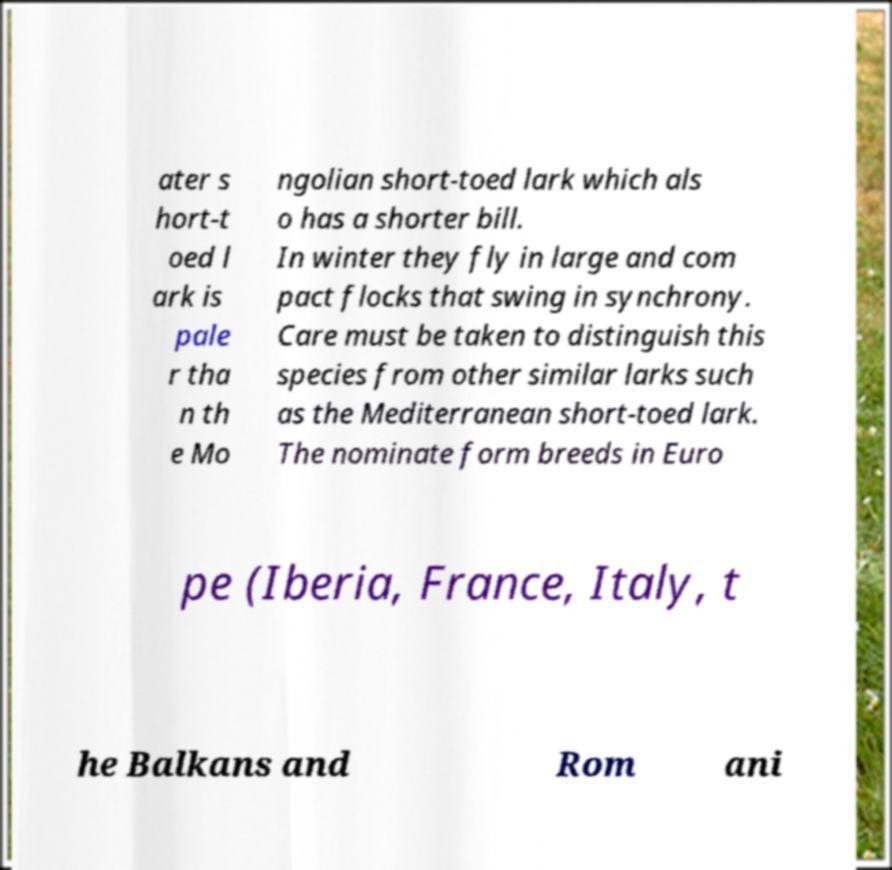For documentation purposes, I need the text within this image transcribed. Could you provide that? ater s hort-t oed l ark is pale r tha n th e Mo ngolian short-toed lark which als o has a shorter bill. In winter they fly in large and com pact flocks that swing in synchrony. Care must be taken to distinguish this species from other similar larks such as the Mediterranean short-toed lark. The nominate form breeds in Euro pe (Iberia, France, Italy, t he Balkans and Rom ani 